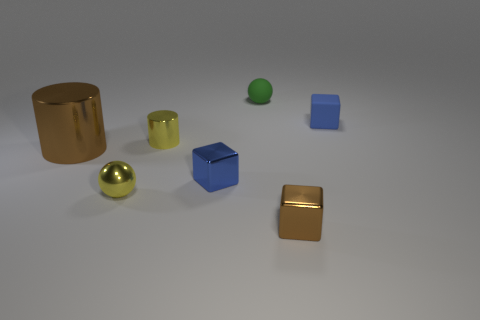Subtract all brown cubes. How many cubes are left? 2 Subtract all brown cylinders. How many cylinders are left? 1 Add 1 brown cylinders. How many objects exist? 8 Subtract 3 blocks. How many blocks are left? 0 Subtract all cubes. How many objects are left? 4 Subtract 0 red balls. How many objects are left? 7 Subtract all purple cylinders. Subtract all gray balls. How many cylinders are left? 2 Subtract all gray cylinders. How many blue blocks are left? 2 Subtract all red spheres. Subtract all tiny yellow metal balls. How many objects are left? 6 Add 6 large things. How many large things are left? 7 